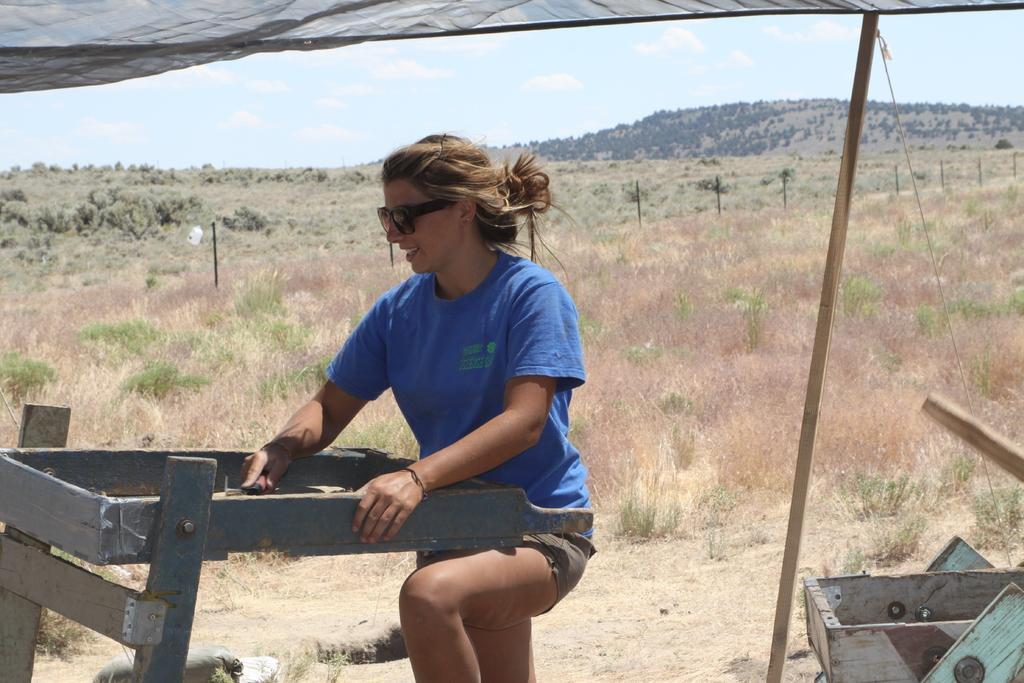Please provide a concise description of this image. In the center of the image there is a woman standing and wearing spectacles. In the background we can see plants, grass, fencing, hill, trees, sky and clouds. 